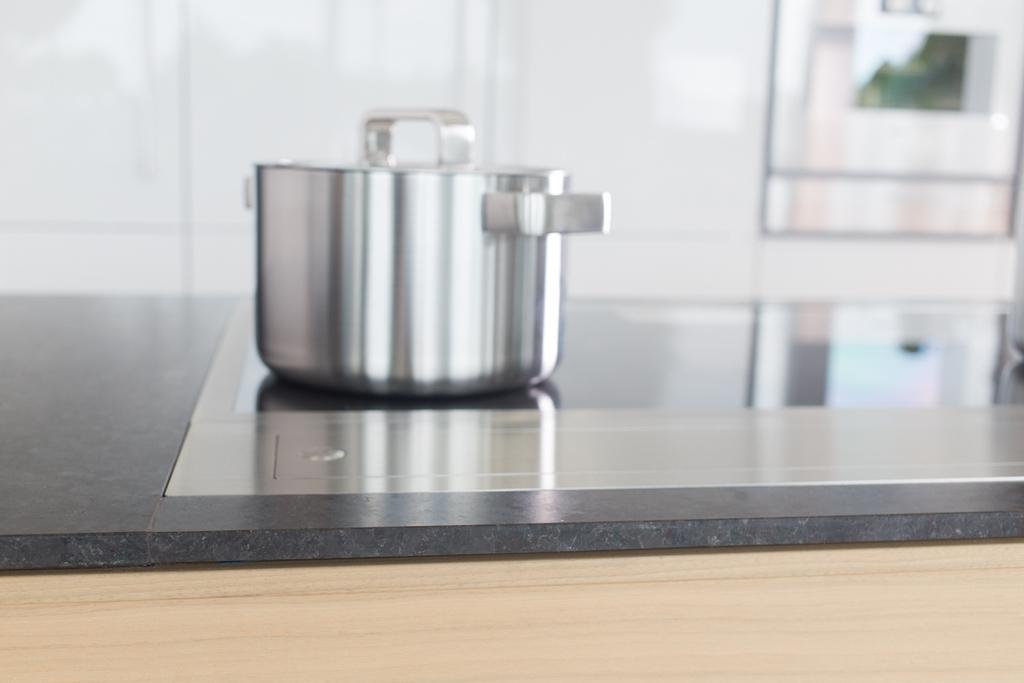In one or two sentences, can you explain what this image depicts? In this picture we can see steel bowl on the kitchen platform. On the top right there is a oven. Here we can see a wooden wall which is near to the white color. On the bottom we can see a wood. 